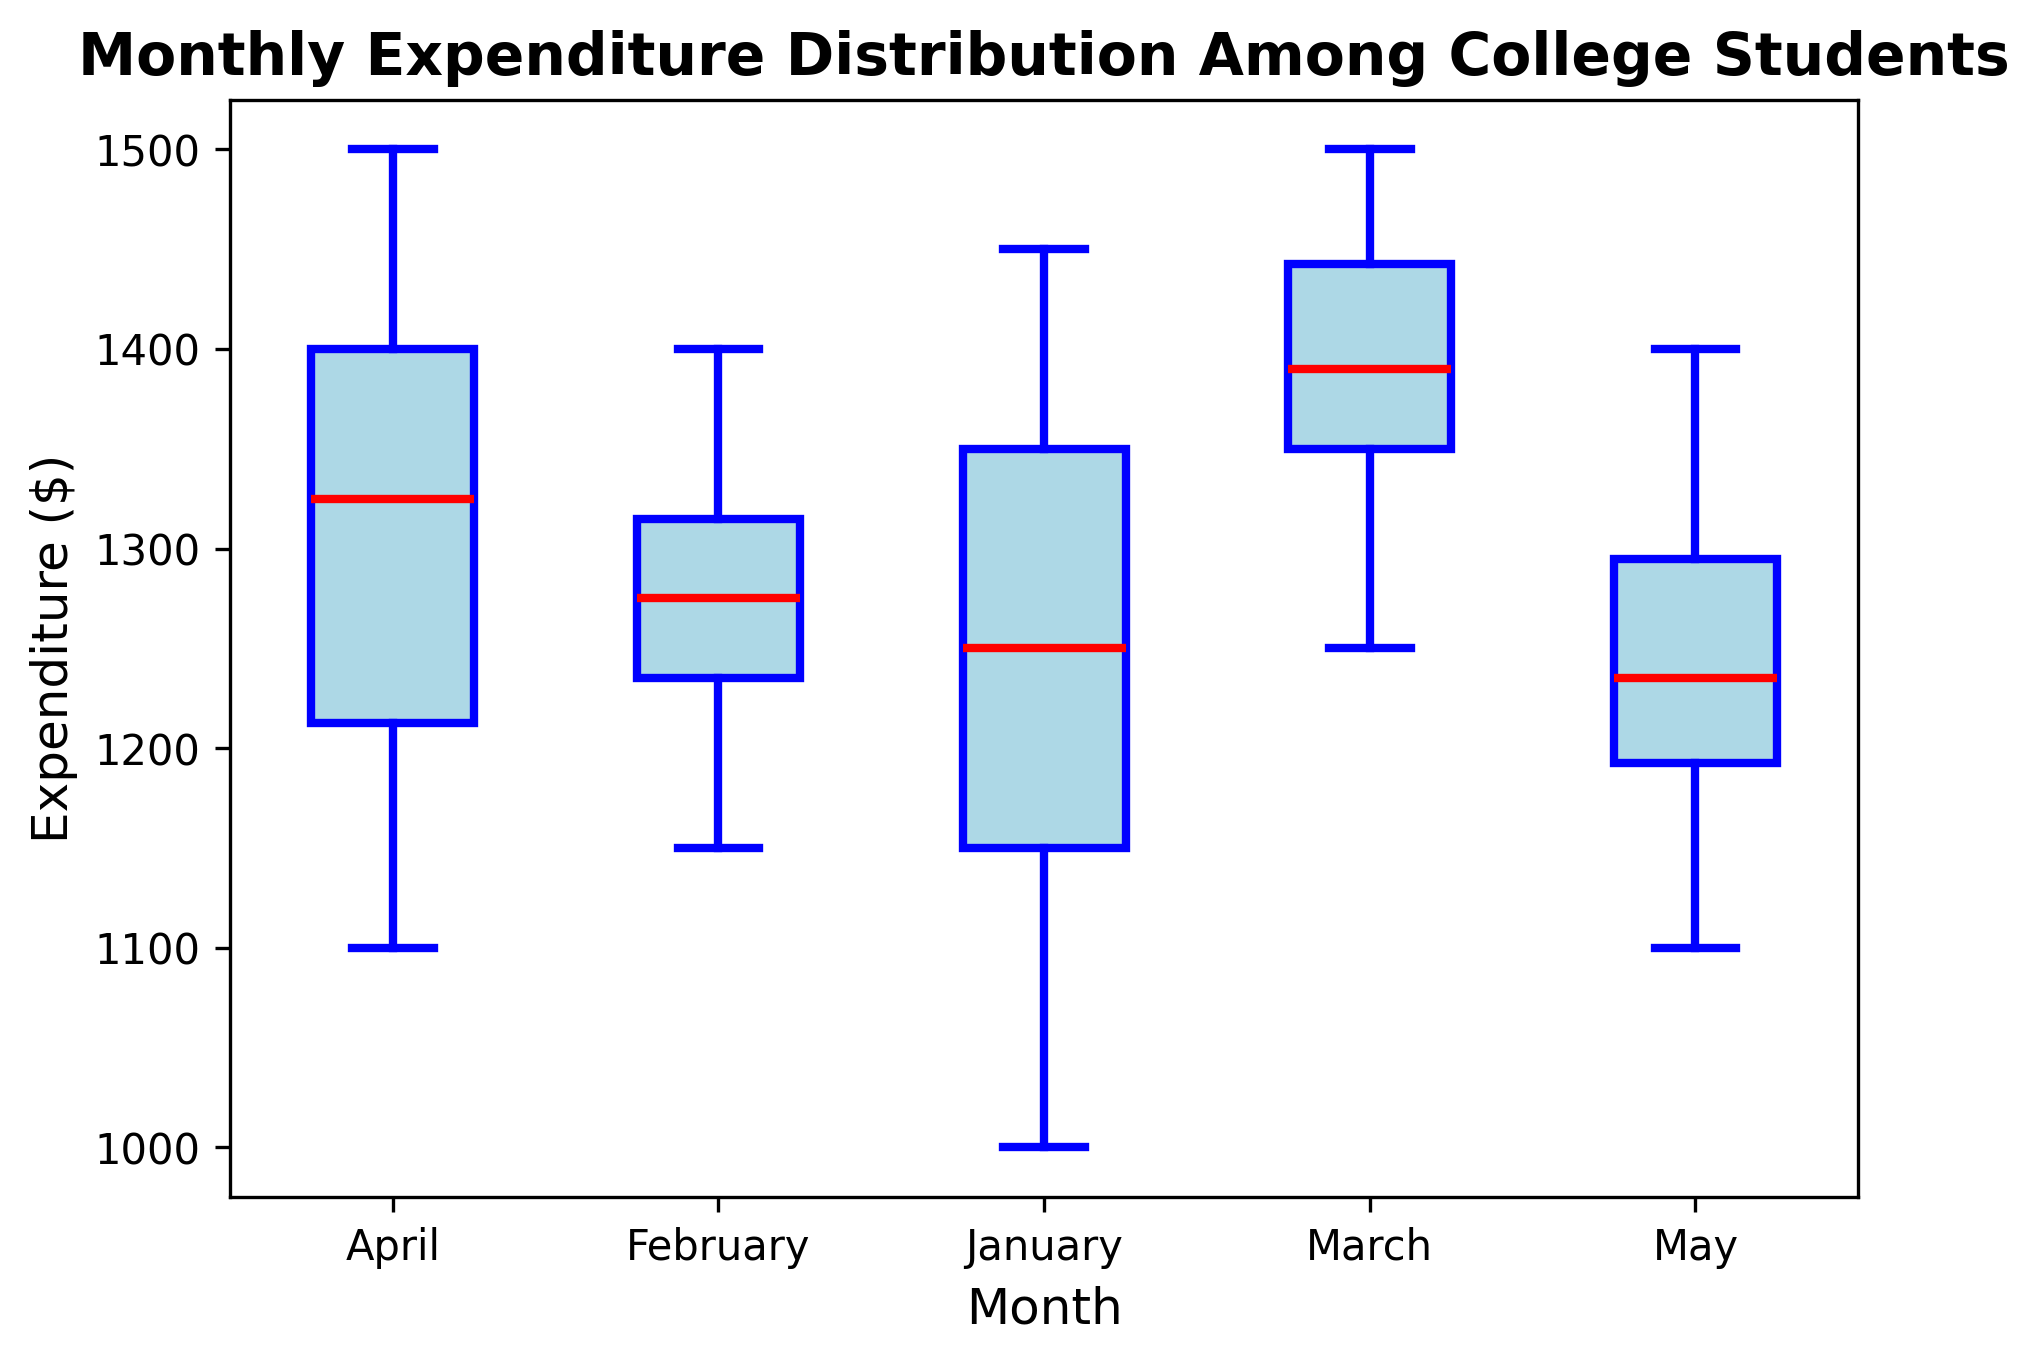Which month has the highest median expenditure? The box plot shows the red line inside each box representing the median expenditure for each month. By comparing the red lines, we see that March has the highest median expenditure.
Answer: March Which month has the greatest range of expenditures? The range of expenditures is the difference between the highest and lowest values in each month's box plot. April has the greatest difference between the top whisker (max value) and the bottom whisker (min value), indicating it has the greatest range.
Answer: April Which month has the smallest interquartile range (IQR) for expenditures? The IQR is the range between the upper quartile (top edge of the box) and the lower quartile (bottom edge of the box). By visually comparing the height of the boxes, May has the smallest box, indicating the smallest IQR.
Answer: May How does the median expenditure in February compare to January? The red median line of February is higher than that of January in the box plot, indicating that the median expenditure in February is higher than in January.
Answer: February is higher Which months have any outliers, and how can you identify them? Outliers are represented by individual points outside the whiskers of the box plot. By looking at the box plot, January, May, April, and March have outliers indicated by individual points.
Answer: January, May, April, March What is the median expenditure value in March? The red line in the March box plot indicates the median expenditure. By visually checking the Y-axis scale aligned with the median in March, the value appears to be around 1400.
Answer: 1400 What can you say about the expenditure distribution in January versus May? Comparing the two months, January has a larger spread (greater range) than May. January also has higher maximum and minimum values, while May's expenditures are more tightly grouped, indicating less variability.
Answer: January has a larger spread Which month shows the least variability in spending? Variability can be assessed by the spread of data, indicated by the height of the box and whiskers. May has the smallest box and shorter whiskers, indicating the least variability in spending.
Answer: May During which month do students have the highest upper quartile value? The upper quartile is indicated by the top edge of the box. By checking the plots, April shows the highest upper quartile value on the Y-axis scale.
Answer: April 